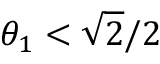<formula> <loc_0><loc_0><loc_500><loc_500>\theta _ { 1 } < \sqrt { 2 } / 2</formula> 